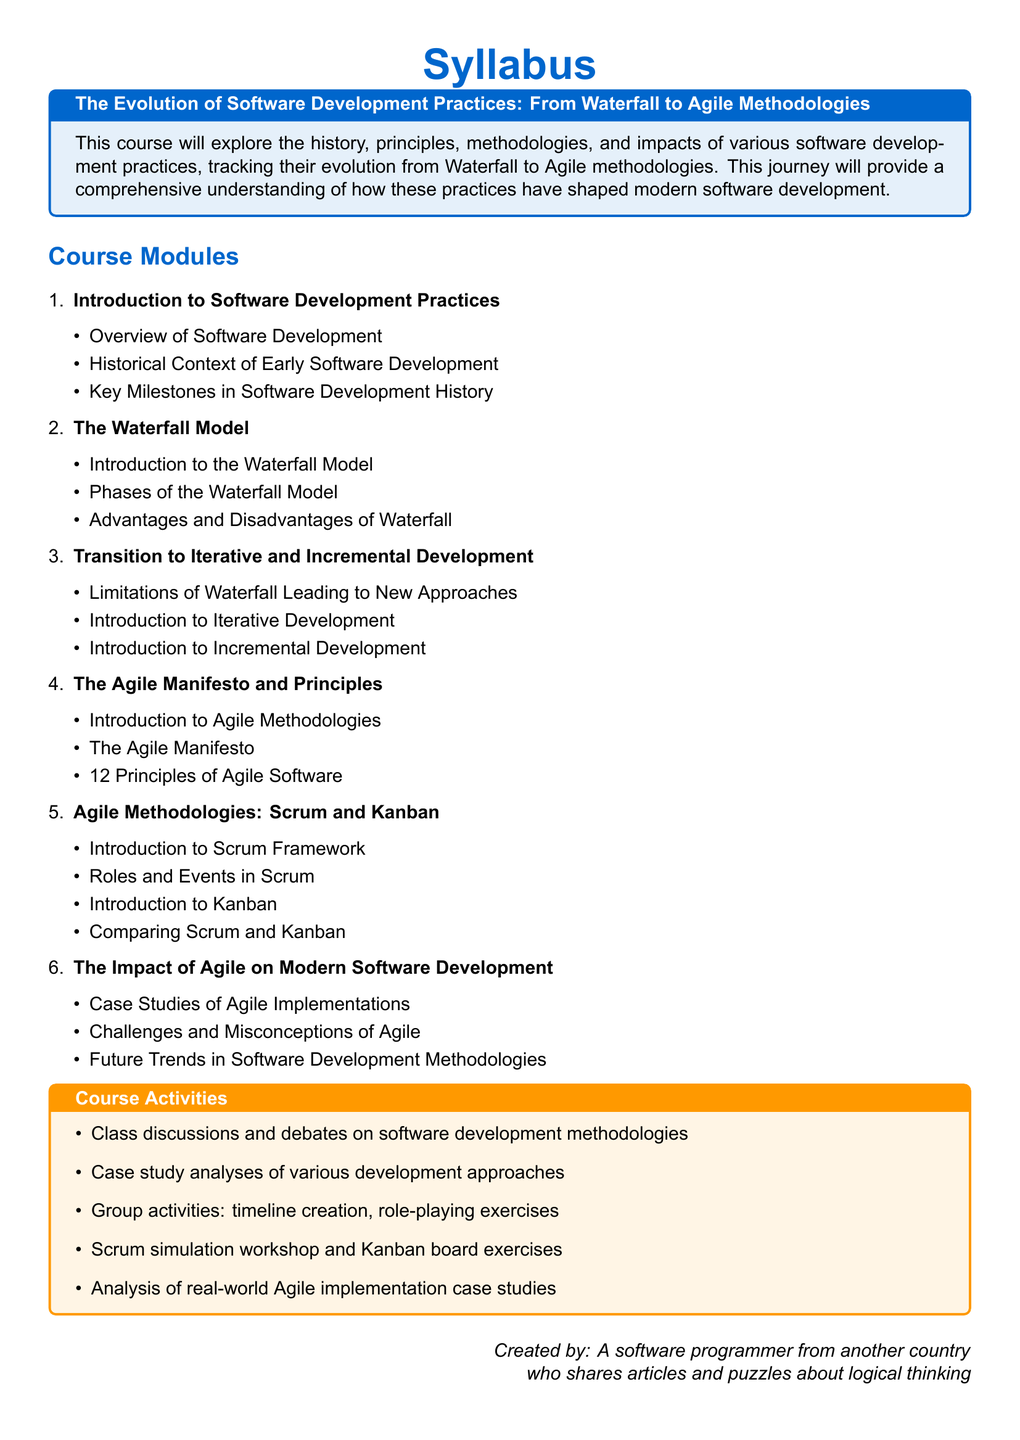What is the title of the syllabus? The title of the syllabus highlights the main focus of the course, which is "The Evolution of Software Development Practices: From Waterfall to Agile Methodologies."
Answer: The Evolution of Software Development Practices: From Waterfall to Agile Methodologies How many modules are included in the syllabus? The document lists a total of six modules under the course modules section.
Answer: 6 What is one of the advantages discussed about the Waterfall model? The document does not specify any advantages but states that the module covers advantages of the Waterfall model; thus, understanding the module would provide insights on that topic.
Answer: Advantages of Waterfall What are two methodologies mentioned under Agile methodologies? The syllabus lists Scrum and Kanban as specific agile methodologies explored in the course.
Answer: Scrum and Kanban What is the focus of the final module in the syllabus? The focus of the final module is on the impact of Agile on modern software development practices.
Answer: The Impact of Agile on Modern Software Development How many principles are outlined in the Agile Manifesto? The syllabus specifies that there are twelve principles of Agile software that are covered within the course.
Answer: 12 Principles 